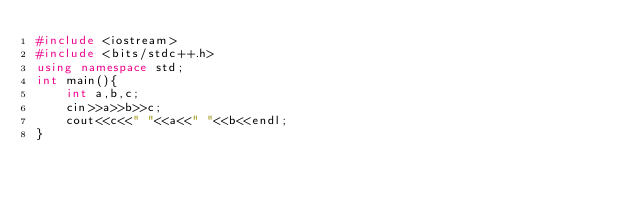<code> <loc_0><loc_0><loc_500><loc_500><_C++_>#include <iostream>
#include <bits/stdc++.h>
using namespace std;
int main(){
    int a,b,c;
    cin>>a>>b>>c;
    cout<<c<<" "<<a<<" "<<b<<endl;    
}</code> 